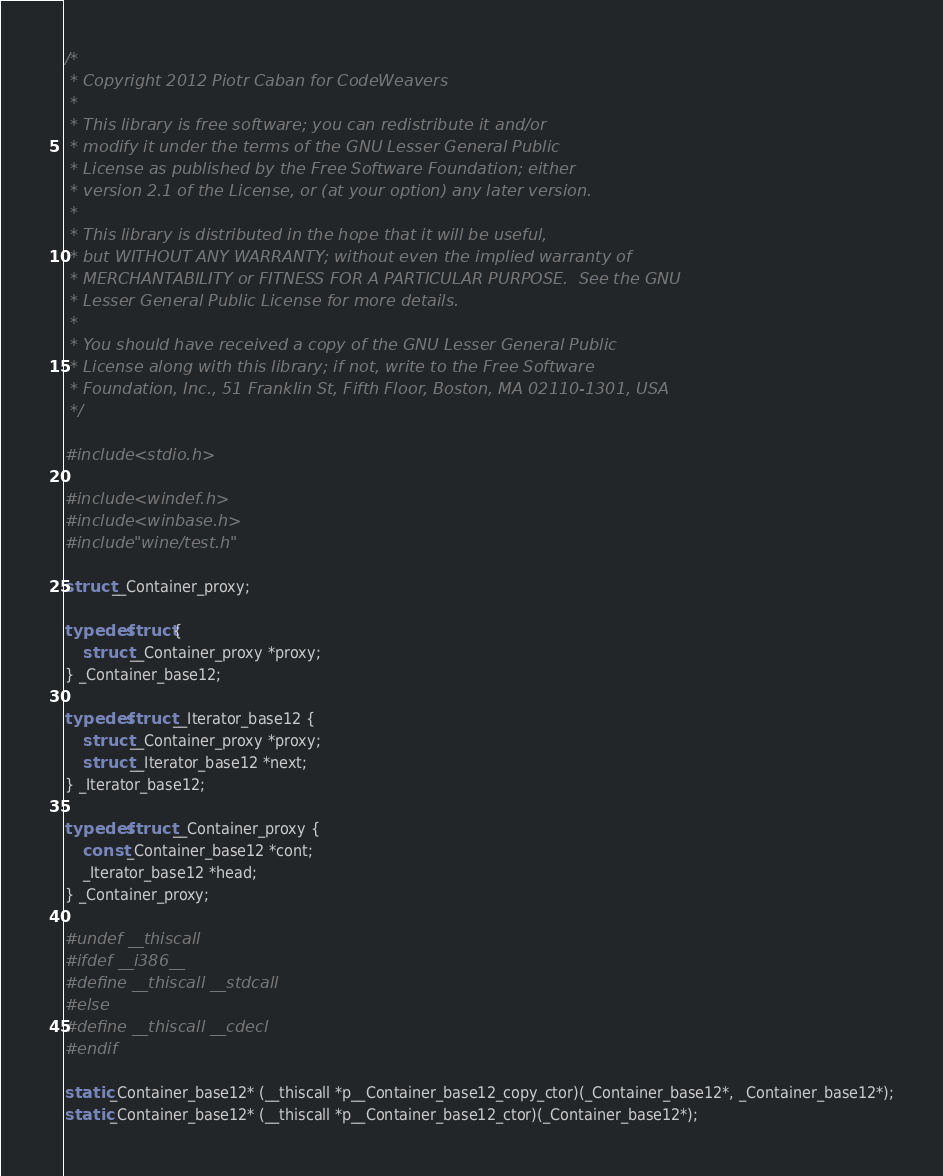<code> <loc_0><loc_0><loc_500><loc_500><_C_>/*
 * Copyright 2012 Piotr Caban for CodeWeavers
 *
 * This library is free software; you can redistribute it and/or
 * modify it under the terms of the GNU Lesser General Public
 * License as published by the Free Software Foundation; either
 * version 2.1 of the License, or (at your option) any later version.
 *
 * This library is distributed in the hope that it will be useful,
 * but WITHOUT ANY WARRANTY; without even the implied warranty of
 * MERCHANTABILITY or FITNESS FOR A PARTICULAR PURPOSE.  See the GNU
 * Lesser General Public License for more details.
 *
 * You should have received a copy of the GNU Lesser General Public
 * License along with this library; if not, write to the Free Software
 * Foundation, Inc., 51 Franklin St, Fifth Floor, Boston, MA 02110-1301, USA
 */

#include <stdio.h>

#include <windef.h>
#include <winbase.h>
#include "wine/test.h"

struct __Container_proxy;

typedef struct {
    struct __Container_proxy *proxy;
} _Container_base12;

typedef struct __Iterator_base12 {
    struct __Container_proxy *proxy;
    struct __Iterator_base12 *next;
} _Iterator_base12;

typedef struct __Container_proxy {
    const _Container_base12 *cont;
    _Iterator_base12 *head;
} _Container_proxy;

#undef __thiscall
#ifdef __i386__
#define __thiscall __stdcall
#else
#define __thiscall __cdecl
#endif

static _Container_base12* (__thiscall *p__Container_base12_copy_ctor)(_Container_base12*, _Container_base12*);
static _Container_base12* (__thiscall *p__Container_base12_ctor)(_Container_base12*);</code> 